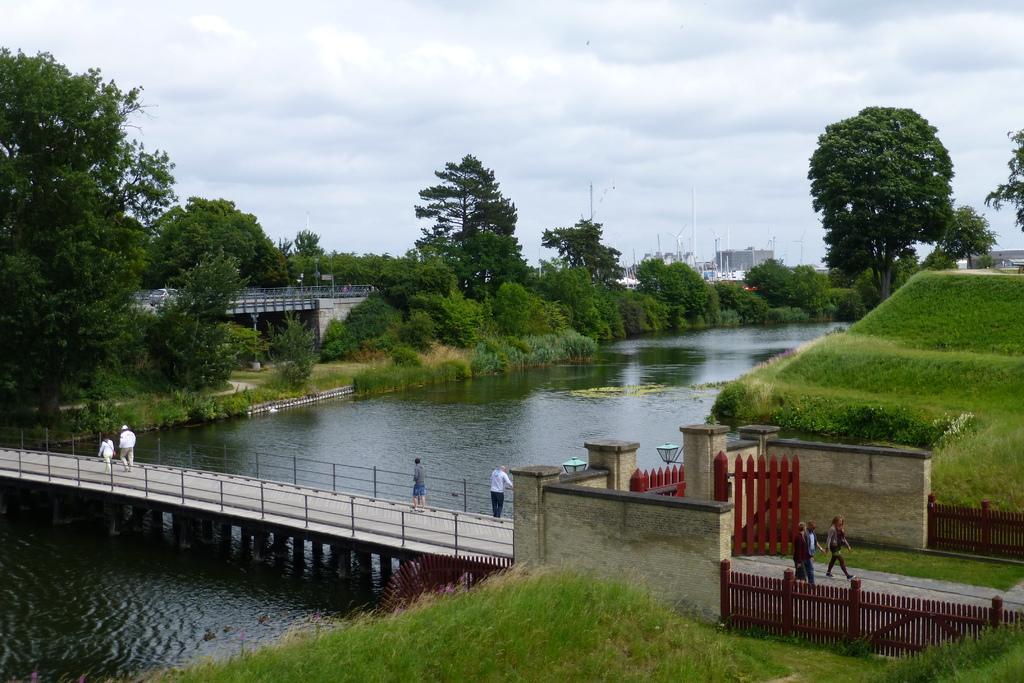Could you give a brief overview of what you see in this image? In this picture we can see there are some people walking and some people are standing on the bridge. On the right side of the bridge there are walls, a gate and the fence. Behind the fence there is the water, plants, trees, poles, buildings and the sky. 